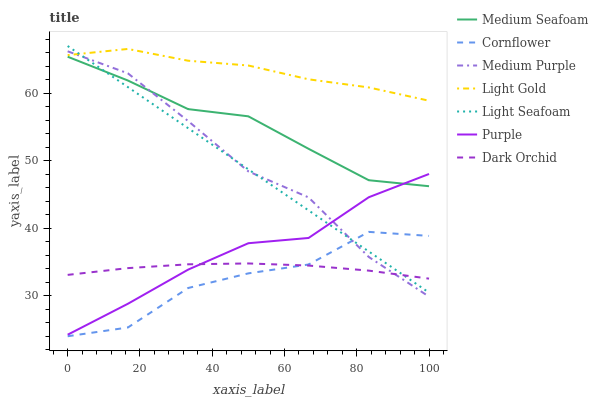Does Cornflower have the minimum area under the curve?
Answer yes or no. Yes. Does Light Gold have the maximum area under the curve?
Answer yes or no. Yes. Does Purple have the minimum area under the curve?
Answer yes or no. No. Does Purple have the maximum area under the curve?
Answer yes or no. No. Is Light Seafoam the smoothest?
Answer yes or no. Yes. Is Cornflower the roughest?
Answer yes or no. Yes. Is Purple the smoothest?
Answer yes or no. No. Is Purple the roughest?
Answer yes or no. No. Does Purple have the lowest value?
Answer yes or no. No. Does Purple have the highest value?
Answer yes or no. No. Is Dark Orchid less than Medium Seafoam?
Answer yes or no. Yes. Is Medium Seafoam greater than Dark Orchid?
Answer yes or no. Yes. Does Dark Orchid intersect Medium Seafoam?
Answer yes or no. No. 